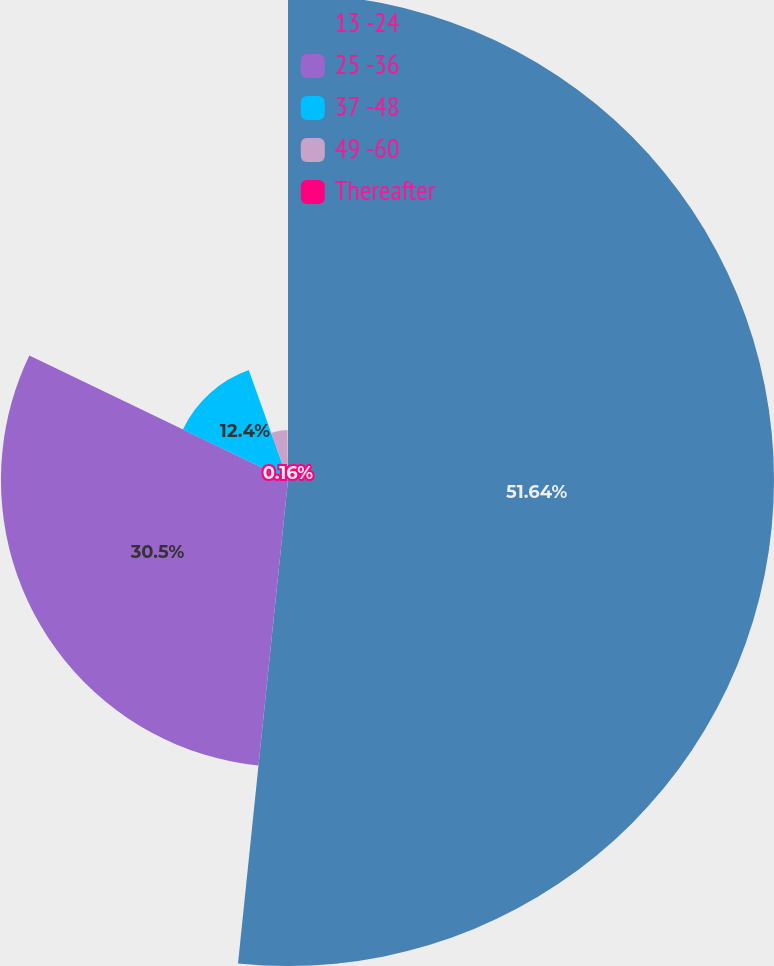Convert chart to OTSL. <chart><loc_0><loc_0><loc_500><loc_500><pie_chart><fcel>13 -24<fcel>25 -36<fcel>37 -48<fcel>49 -60<fcel>Thereafter<nl><fcel>51.64%<fcel>30.5%<fcel>12.4%<fcel>5.3%<fcel>0.16%<nl></chart> 